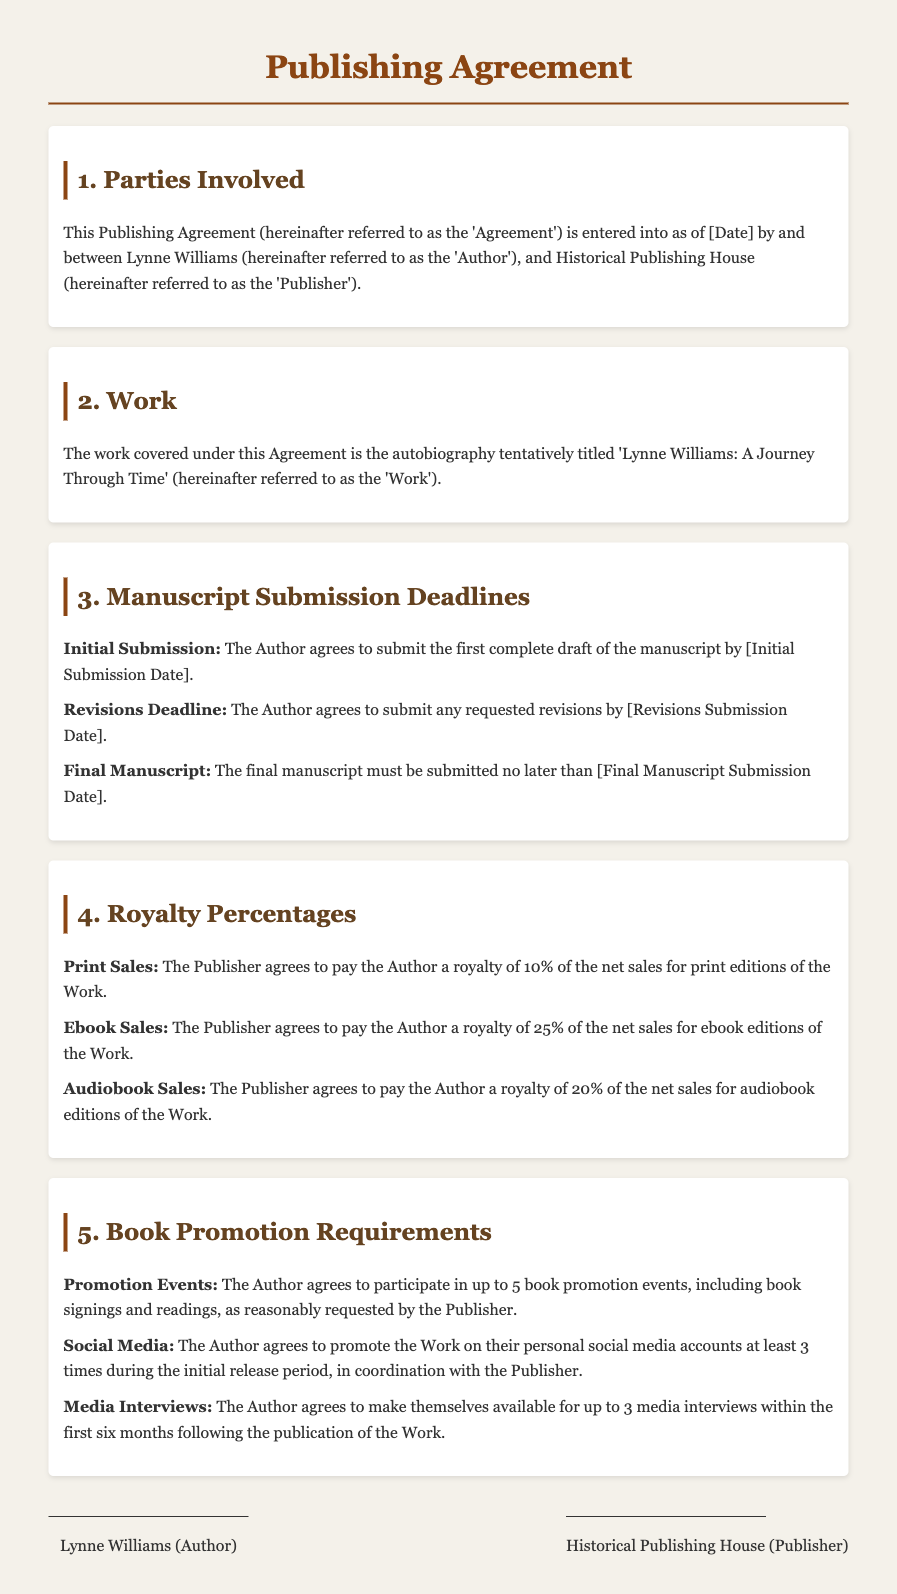What is the title of the autobiography? The title of the autobiography is specified in the document as 'Lynne Williams: A Journey Through Time'.
Answer: Lynne Williams: A Journey Through Time When is the initial submission date for the manuscript? The initial submission date for the manuscript is noted in the section about manuscript submission deadlines, where it specifies that the date is to be filled in.
Answer: [Initial Submission Date] What percentage of net sales will the author receive for ebook sales? The document states the royalty percentage for the ebook sales explicitly under the royalty percentages section.
Answer: 25% How many book promotion events is the author required to participate in? The number of book promotion events is clearly stated in the section outlining the book promotion requirements.
Answer: 5 What is the royalty percentage for audiobook sales? The document includes the royalty percentage for audiobook sales under the royalty percentages section.
Answer: 20% How many media interviews must the author make themselves available for? The required number of media interviews is mentioned in the book promotion requirements section of the agreement.
Answer: 3 What is the final manuscript submission deadline? The final manuscript submission deadline is specified to be filled in within the section regarding manuscript submission deadlines.
Answer: [Final Manuscript Submission Date] What type of document is this? The type of document is indicated at the top of the rendered document as a Publishing Agreement.
Answer: Publishing Agreement 